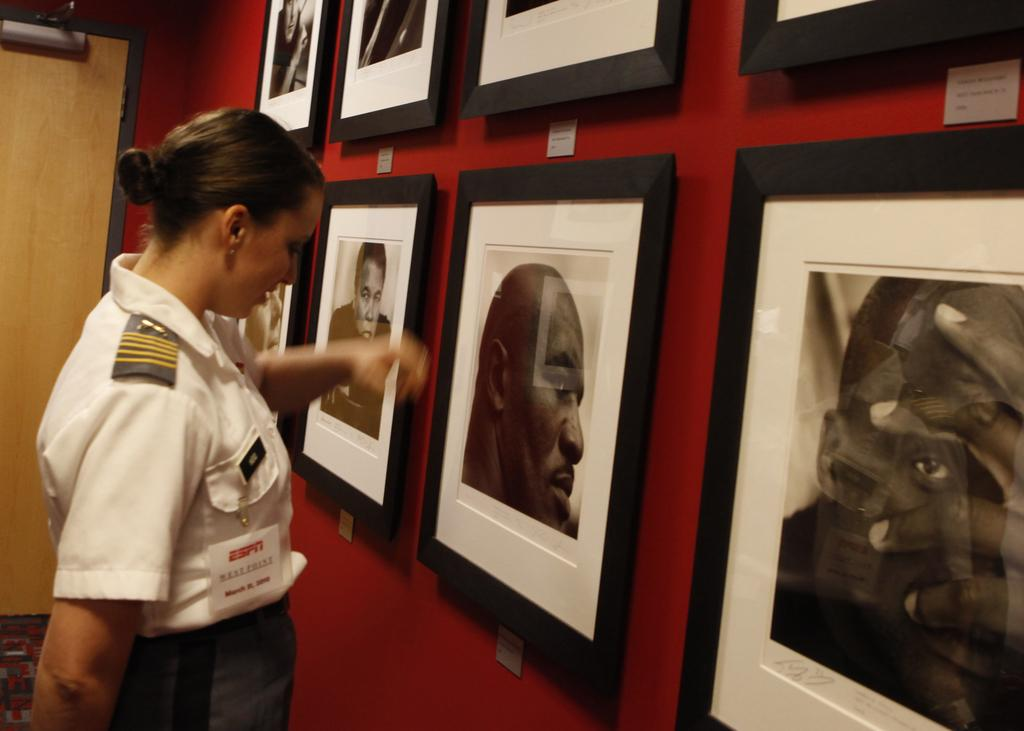Who is on the left side of the image? There is a woman on the left side of the image. What can be seen on the wall in the image? There are frames on the wall in the image. What architectural feature is visible in the background of the image? There is a door visible in the background of the image. What type of glass is the woman holding in the image? There is no glass present in the image; the woman is not holding anything. 